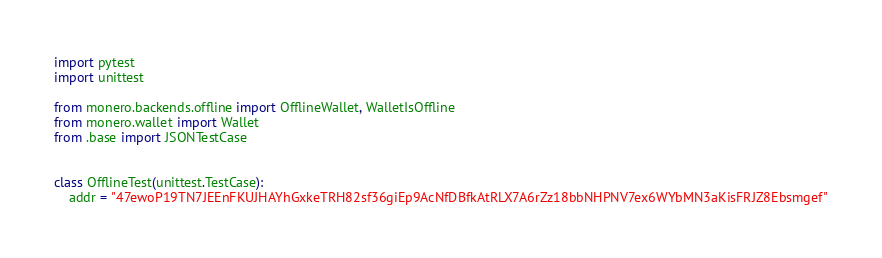Convert code to text. <code><loc_0><loc_0><loc_500><loc_500><_Python_>import pytest
import unittest

from monero.backends.offline import OfflineWallet, WalletIsOffline
from monero.wallet import Wallet
from .base import JSONTestCase


class OfflineTest(unittest.TestCase):
    addr = "47ewoP19TN7JEEnFKUJHAYhGxkeTRH82sf36giEp9AcNfDBfkAtRLX7A6rZz18bbNHPNV7ex6WYbMN3aKisFRJZ8Ebsmgef"</code> 